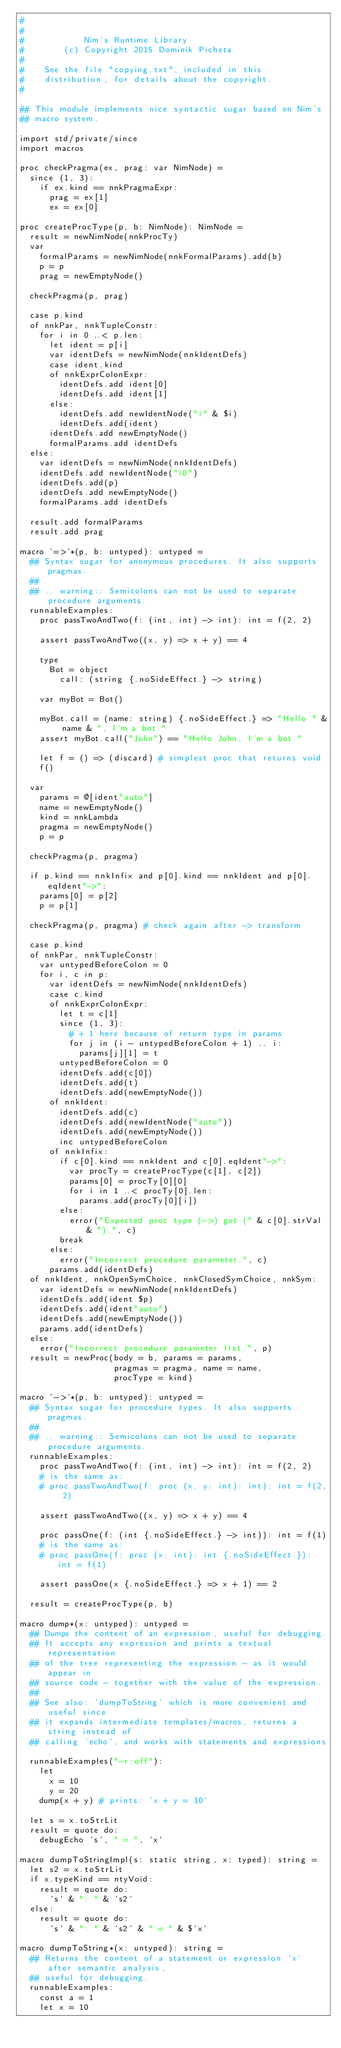Convert code to text. <code><loc_0><loc_0><loc_500><loc_500><_Nim_>#
#
#            Nim's Runtime Library
#        (c) Copyright 2015 Dominik Picheta
#
#    See the file "copying.txt", included in this
#    distribution, for details about the copyright.
#

## This module implements nice syntactic sugar based on Nim's
## macro system.

import std/private/since
import macros

proc checkPragma(ex, prag: var NimNode) =
  since (1, 3):
    if ex.kind == nnkPragmaExpr:
      prag = ex[1]
      ex = ex[0]

proc createProcType(p, b: NimNode): NimNode =
  result = newNimNode(nnkProcTy)
  var
    formalParams = newNimNode(nnkFormalParams).add(b)
    p = p
    prag = newEmptyNode()

  checkPragma(p, prag)

  case p.kind
  of nnkPar, nnkTupleConstr:
    for i in 0 ..< p.len:
      let ident = p[i]
      var identDefs = newNimNode(nnkIdentDefs)
      case ident.kind
      of nnkExprColonExpr:
        identDefs.add ident[0]
        identDefs.add ident[1]
      else:
        identDefs.add newIdentNode("i" & $i)
        identDefs.add(ident)
      identDefs.add newEmptyNode()
      formalParams.add identDefs
  else:
    var identDefs = newNimNode(nnkIdentDefs)
    identDefs.add newIdentNode("i0")
    identDefs.add(p)
    identDefs.add newEmptyNode()
    formalParams.add identDefs

  result.add formalParams
  result.add prag

macro `=>`*(p, b: untyped): untyped =
  ## Syntax sugar for anonymous procedures. It also supports pragmas.
  ##
  ## .. warning:: Semicolons can not be used to separate procedure arguments.
  runnableExamples:
    proc passTwoAndTwo(f: (int, int) -> int): int = f(2, 2)

    assert passTwoAndTwo((x, y) => x + y) == 4

    type
      Bot = object
        call: (string {.noSideEffect.} -> string)

    var myBot = Bot()

    myBot.call = (name: string) {.noSideEffect.} => "Hello " & name & ", I'm a bot."
    assert myBot.call("John") == "Hello John, I'm a bot."

    let f = () => (discard) # simplest proc that returns void
    f()

  var
    params = @[ident"auto"]
    name = newEmptyNode()
    kind = nnkLambda
    pragma = newEmptyNode()
    p = p

  checkPragma(p, pragma)

  if p.kind == nnkInfix and p[0].kind == nnkIdent and p[0].eqIdent"->":
    params[0] = p[2]
    p = p[1]

  checkPragma(p, pragma) # check again after -> transform

  case p.kind
  of nnkPar, nnkTupleConstr:
    var untypedBeforeColon = 0
    for i, c in p:
      var identDefs = newNimNode(nnkIdentDefs)
      case c.kind
      of nnkExprColonExpr:
        let t = c[1]
        since (1, 3):
          # + 1 here because of return type in params
          for j in (i - untypedBeforeColon + 1) .. i:
            params[j][1] = t
        untypedBeforeColon = 0
        identDefs.add(c[0])
        identDefs.add(t)
        identDefs.add(newEmptyNode())
      of nnkIdent:
        identDefs.add(c)
        identDefs.add(newIdentNode("auto"))
        identDefs.add(newEmptyNode())
        inc untypedBeforeColon
      of nnkInfix:
        if c[0].kind == nnkIdent and c[0].eqIdent"->":
          var procTy = createProcType(c[1], c[2])
          params[0] = procTy[0][0]
          for i in 1 ..< procTy[0].len:
            params.add(procTy[0][i])
        else:
          error("Expected proc type (->) got (" & c[0].strVal & ").", c)
        break
      else:
        error("Incorrect procedure parameter.", c)
      params.add(identDefs)
  of nnkIdent, nnkOpenSymChoice, nnkClosedSymChoice, nnkSym:
    var identDefs = newNimNode(nnkIdentDefs)
    identDefs.add(ident $p)
    identDefs.add(ident"auto")
    identDefs.add(newEmptyNode())
    params.add(identDefs)
  else:
    error("Incorrect procedure parameter list.", p)
  result = newProc(body = b, params = params,
                   pragmas = pragma, name = name,
                   procType = kind)

macro `->`*(p, b: untyped): untyped =
  ## Syntax sugar for procedure types. It also supports pragmas.
  ##
  ## .. warning:: Semicolons can not be used to separate procedure arguments.
  runnableExamples:
    proc passTwoAndTwo(f: (int, int) -> int): int = f(2, 2)
    # is the same as:
    # proc passTwoAndTwo(f: proc (x, y: int): int): int = f(2, 2)

    assert passTwoAndTwo((x, y) => x + y) == 4

    proc passOne(f: (int {.noSideEffect.} -> int)): int = f(1)
    # is the same as:
    # proc passOne(f: proc (x: int): int {.noSideEffect.}): int = f(1)

    assert passOne(x {.noSideEffect.} => x + 1) == 2

  result = createProcType(p, b)

macro dump*(x: untyped): untyped =
  ## Dumps the content of an expression, useful for debugging.
  ## It accepts any expression and prints a textual representation
  ## of the tree representing the expression - as it would appear in
  ## source code - together with the value of the expression.
  ##
  ## See also: `dumpToString` which is more convenient and useful since
  ## it expands intermediate templates/macros, returns a string instead of
  ## calling `echo`, and works with statements and expressions.
  runnableExamples("-r:off"):
    let
      x = 10
      y = 20
    dump(x + y) # prints: `x + y = 30`

  let s = x.toStrLit
  result = quote do:
    debugEcho `s`, " = ", `x`

macro dumpToStringImpl(s: static string, x: typed): string =
  let s2 = x.toStrLit
  if x.typeKind == ntyVoid:
    result = quote do:
      `s` & ": " & `s2`
  else:
    result = quote do:
      `s` & ": " & `s2` & " = " & $`x`

macro dumpToString*(x: untyped): string =
  ## Returns the content of a statement or expression `x` after semantic analysis,
  ## useful for debugging.
  runnableExamples:
    const a = 1
    let x = 10</code> 